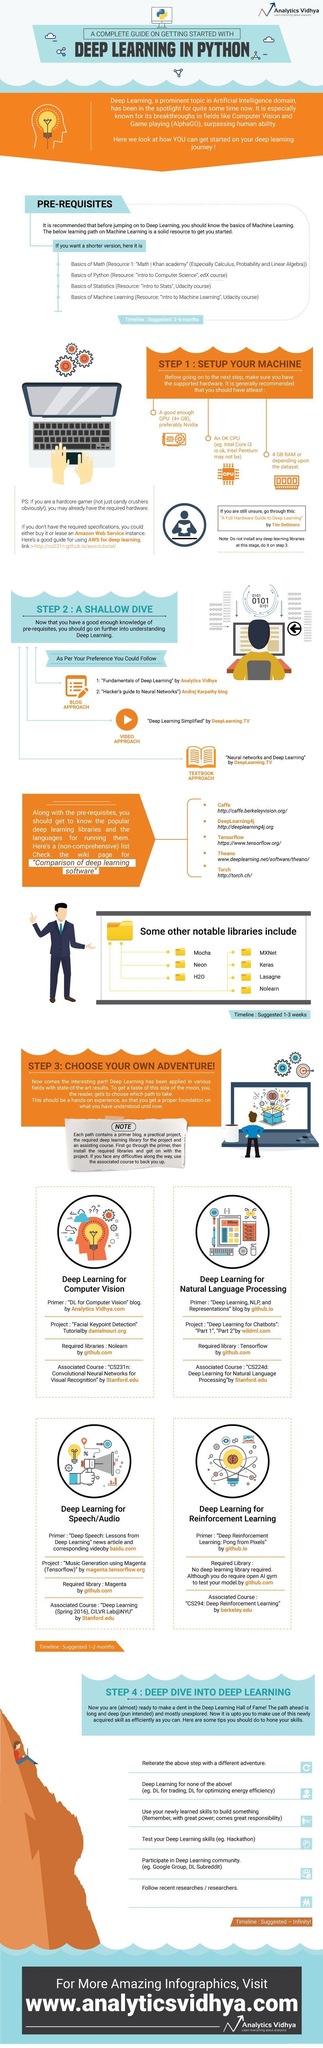Which subject is listed third in the learning path to Machine Learning?
Answer the question with a short phrase. Basics of Statistics What is the timeline suggested for step 4? Infinity Which GPU is recommended for machine setup? Nvidia Which video has been recommended to understand Deep Learning? Deep Learning Simplified Which subject is listed second in the learning path to Machine Learning? Basics of Python For which path is the library Nolearn required? Deep Learning for Computer Vision In Deep Learning for Reinforcement Learning what is required to test your model? open AI gym What is the fourth name in the list of popular deep learning libraries? Theano Which library is required for Deep Learning for Natural Language Processing? Tensorflow Which CPU may not be suitable to setup the machine for Deep Learning? Intel Pentium 